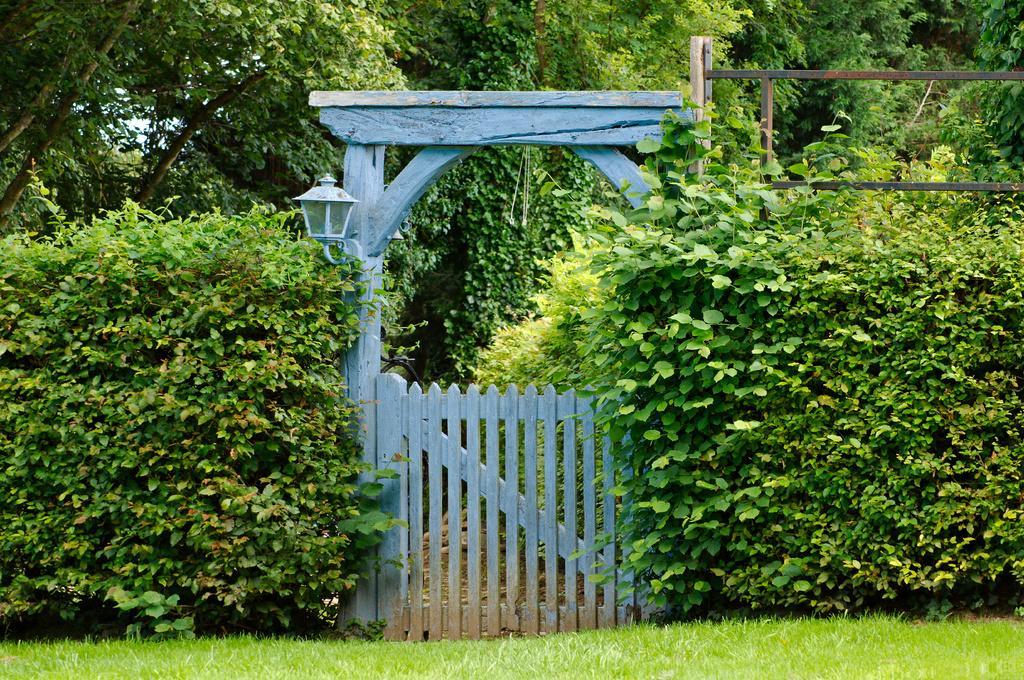Describe this image in one or two sentences. In this picture I can see a wooden gate to which there is an arch, around I can see some trees, plants and grass. 